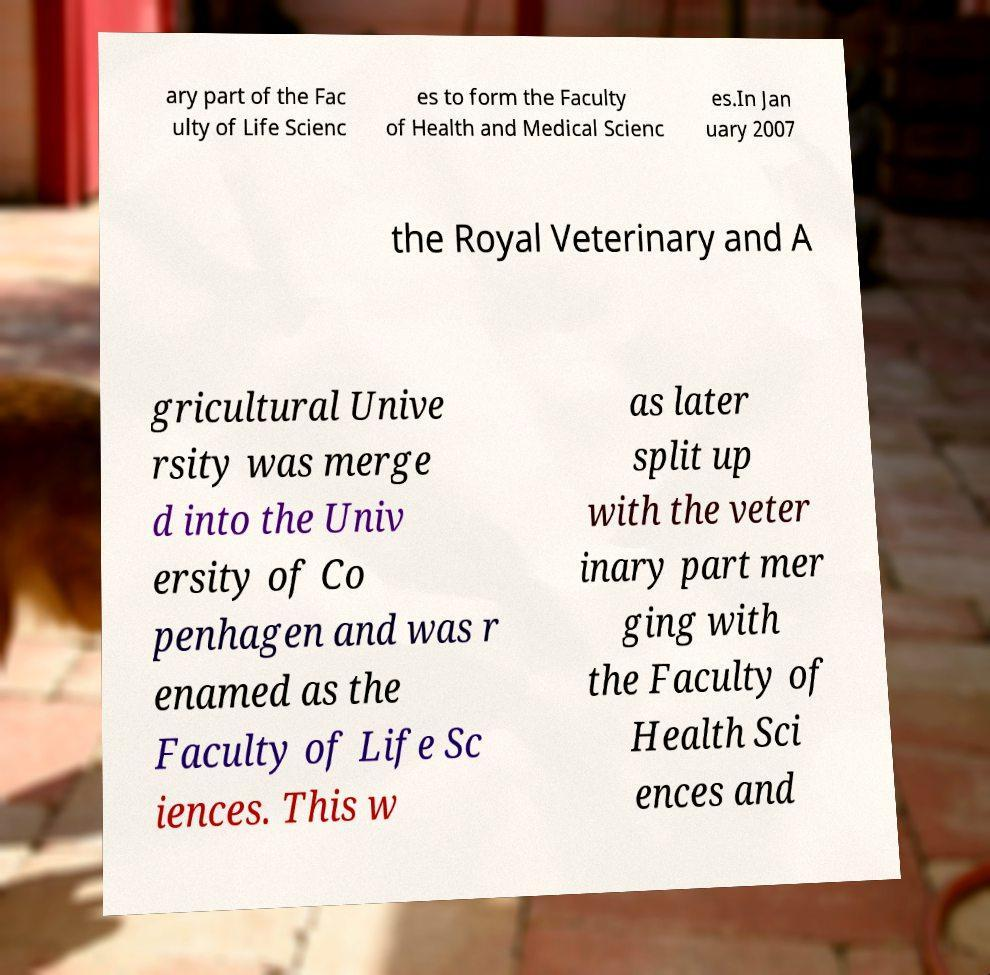Can you read and provide the text displayed in the image?This photo seems to have some interesting text. Can you extract and type it out for me? ary part of the Fac ulty of Life Scienc es to form the Faculty of Health and Medical Scienc es.In Jan uary 2007 the Royal Veterinary and A gricultural Unive rsity was merge d into the Univ ersity of Co penhagen and was r enamed as the Faculty of Life Sc iences. This w as later split up with the veter inary part mer ging with the Faculty of Health Sci ences and 